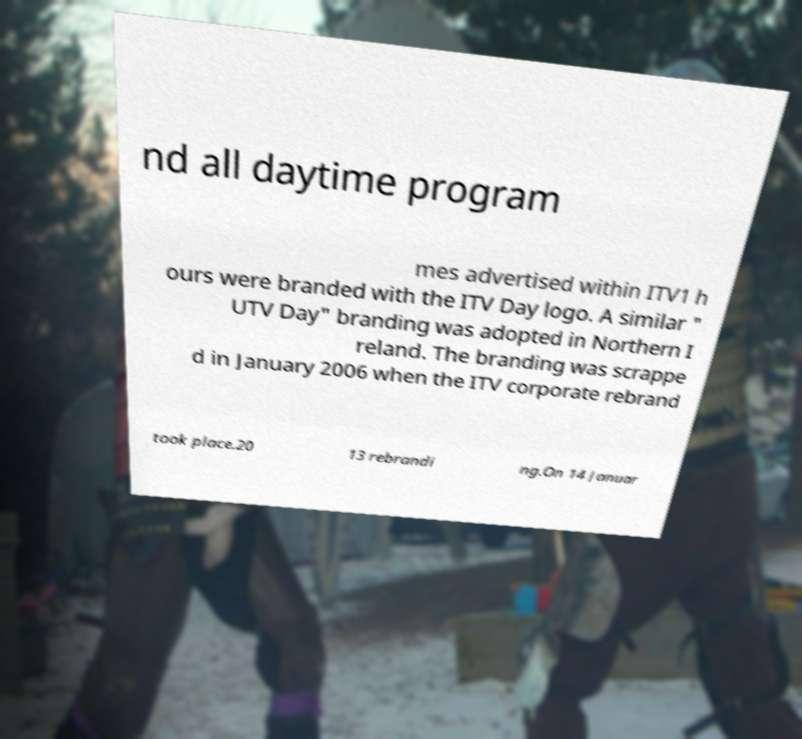Could you assist in decoding the text presented in this image and type it out clearly? nd all daytime program mes advertised within ITV1 h ours were branded with the ITV Day logo. A similar " UTV Day" branding was adopted in Northern I reland. The branding was scrappe d in January 2006 when the ITV corporate rebrand took place.20 13 rebrandi ng.On 14 Januar 